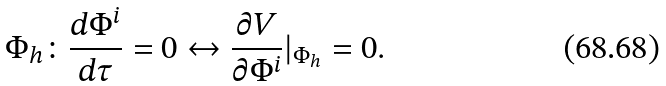<formula> <loc_0><loc_0><loc_500><loc_500>\Phi _ { h } \colon \frac { d \Phi ^ { i } } { d \tau } = 0 \leftrightarrow \frac { \partial V } { \partial \Phi ^ { i } } | _ { \Phi _ { h } } = 0 .</formula> 